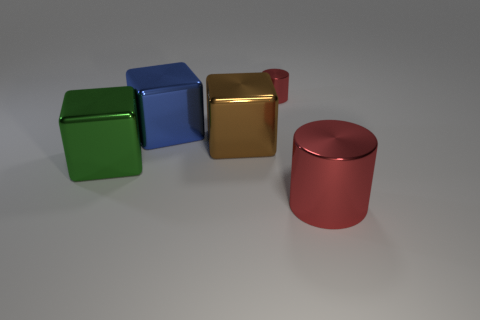Is the color of the big cylinder the same as the tiny metal object?
Ensure brevity in your answer.  Yes. Are there any other things that have the same color as the big cylinder?
Your response must be concise. Yes. Are there any shiny things in front of the green shiny cube?
Offer a very short reply. Yes. There is a red metallic cylinder that is on the right side of the red metallic cylinder that is behind the big brown cube; how big is it?
Provide a short and direct response. Large. Is the number of large green cubes behind the big brown metal block the same as the number of big brown objects that are in front of the green object?
Give a very brief answer. Yes. There is a metallic object that is in front of the large green object; is there a big blue metal cube left of it?
Offer a very short reply. Yes. How many large brown cubes are behind the large object right of the cylinder behind the green shiny thing?
Keep it short and to the point. 1. Is the number of tiny brown shiny cubes less than the number of large red shiny things?
Make the answer very short. Yes. Do the red metallic object behind the large cylinder and the red object that is right of the tiny metallic cylinder have the same shape?
Ensure brevity in your answer.  Yes. The big metallic cylinder is what color?
Your answer should be compact. Red. 